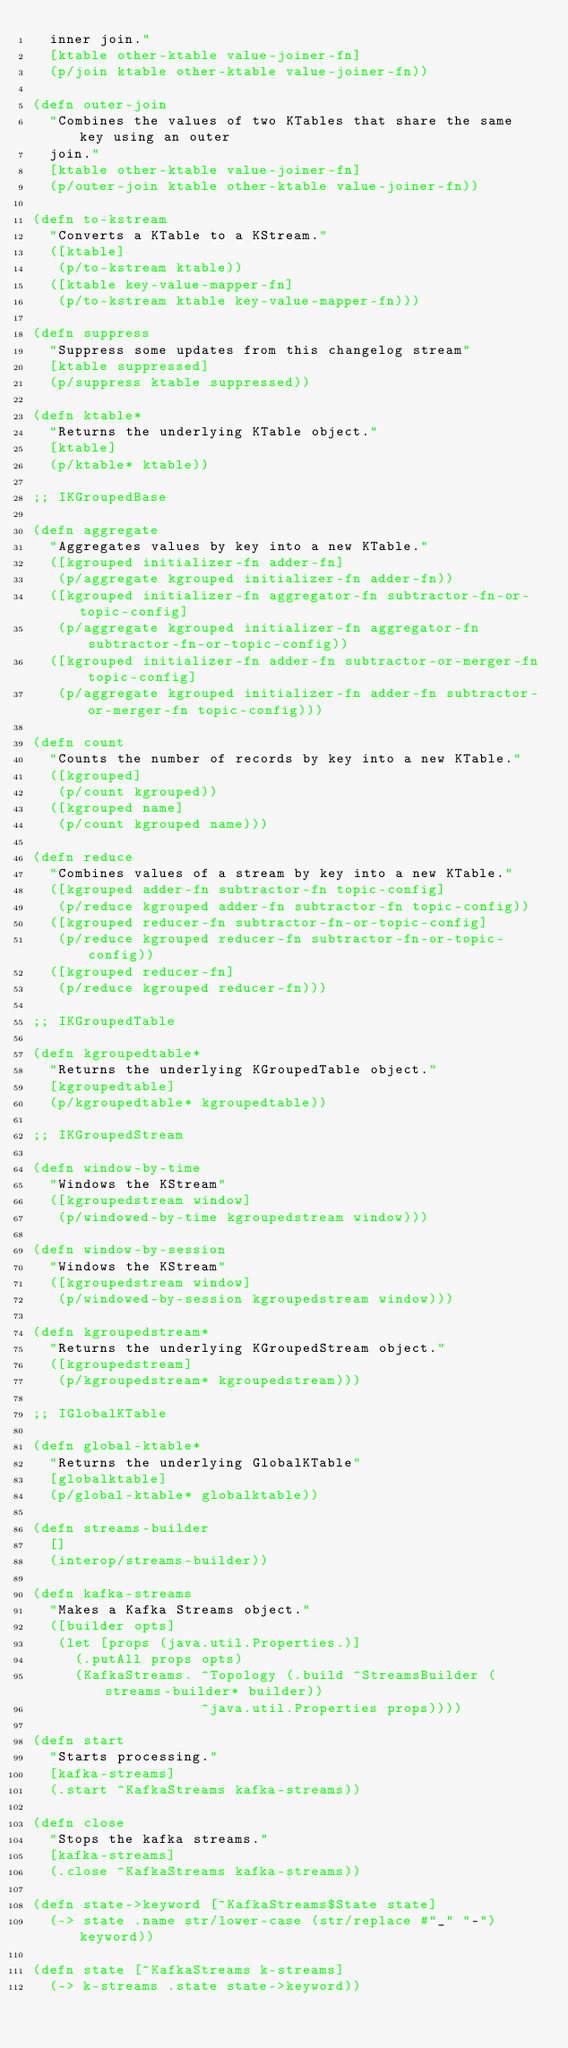<code> <loc_0><loc_0><loc_500><loc_500><_Clojure_>  inner join."
  [ktable other-ktable value-joiner-fn]
  (p/join ktable other-ktable value-joiner-fn))

(defn outer-join
  "Combines the values of two KTables that share the same key using an outer
  join."
  [ktable other-ktable value-joiner-fn]
  (p/outer-join ktable other-ktable value-joiner-fn))

(defn to-kstream
  "Converts a KTable to a KStream."
  ([ktable]
   (p/to-kstream ktable))
  ([ktable key-value-mapper-fn]
   (p/to-kstream ktable key-value-mapper-fn)))

(defn suppress
  "Suppress some updates from this changelog stream"
  [ktable suppressed]
  (p/suppress ktable suppressed))

(defn ktable*
  "Returns the underlying KTable object."
  [ktable]
  (p/ktable* ktable))

;; IKGroupedBase

(defn aggregate
  "Aggregates values by key into a new KTable."
  ([kgrouped initializer-fn adder-fn]
   (p/aggregate kgrouped initializer-fn adder-fn))
  ([kgrouped initializer-fn aggregator-fn subtractor-fn-or-topic-config]
   (p/aggregate kgrouped initializer-fn aggregator-fn subtractor-fn-or-topic-config))
  ([kgrouped initializer-fn adder-fn subtractor-or-merger-fn topic-config]
   (p/aggregate kgrouped initializer-fn adder-fn subtractor-or-merger-fn topic-config)))

(defn count
  "Counts the number of records by key into a new KTable."
  ([kgrouped]
   (p/count kgrouped))
  ([kgrouped name]
   (p/count kgrouped name)))

(defn reduce
  "Combines values of a stream by key into a new KTable."
  ([kgrouped adder-fn subtractor-fn topic-config]
   (p/reduce kgrouped adder-fn subtractor-fn topic-config))
  ([kgrouped reducer-fn subtractor-fn-or-topic-config]
   (p/reduce kgrouped reducer-fn subtractor-fn-or-topic-config))
  ([kgrouped reducer-fn]
   (p/reduce kgrouped reducer-fn)))

;; IKGroupedTable

(defn kgroupedtable*
  "Returns the underlying KGroupedTable object."
  [kgroupedtable]
  (p/kgroupedtable* kgroupedtable))

;; IKGroupedStream

(defn window-by-time
  "Windows the KStream"
  ([kgroupedstream window]
   (p/windowed-by-time kgroupedstream window)))

(defn window-by-session
  "Windows the KStream"
  ([kgroupedstream window]
   (p/windowed-by-session kgroupedstream window)))

(defn kgroupedstream*
  "Returns the underlying KGroupedStream object."
  ([kgroupedstream]
   (p/kgroupedstream* kgroupedstream)))

;; IGlobalKTable

(defn global-ktable*
  "Returns the underlying GlobalKTable"
  [globalktable]
  (p/global-ktable* globalktable))

(defn streams-builder
  []
  (interop/streams-builder))

(defn kafka-streams
  "Makes a Kafka Streams object."
  ([builder opts]
   (let [props (java.util.Properties.)]
     (.putAll props opts)
     (KafkaStreams. ^Topology (.build ^StreamsBuilder (streams-builder* builder))
                    ^java.util.Properties props))))

(defn start
  "Starts processing."
  [kafka-streams]
  (.start ^KafkaStreams kafka-streams))

(defn close
  "Stops the kafka streams."
  [kafka-streams]
  (.close ^KafkaStreams kafka-streams))

(defn state->keyword [^KafkaStreams$State state]
  (-> state .name str/lower-case (str/replace #"_" "-") keyword))

(defn state [^KafkaStreams k-streams]
  (-> k-streams .state state->keyword))
</code> 